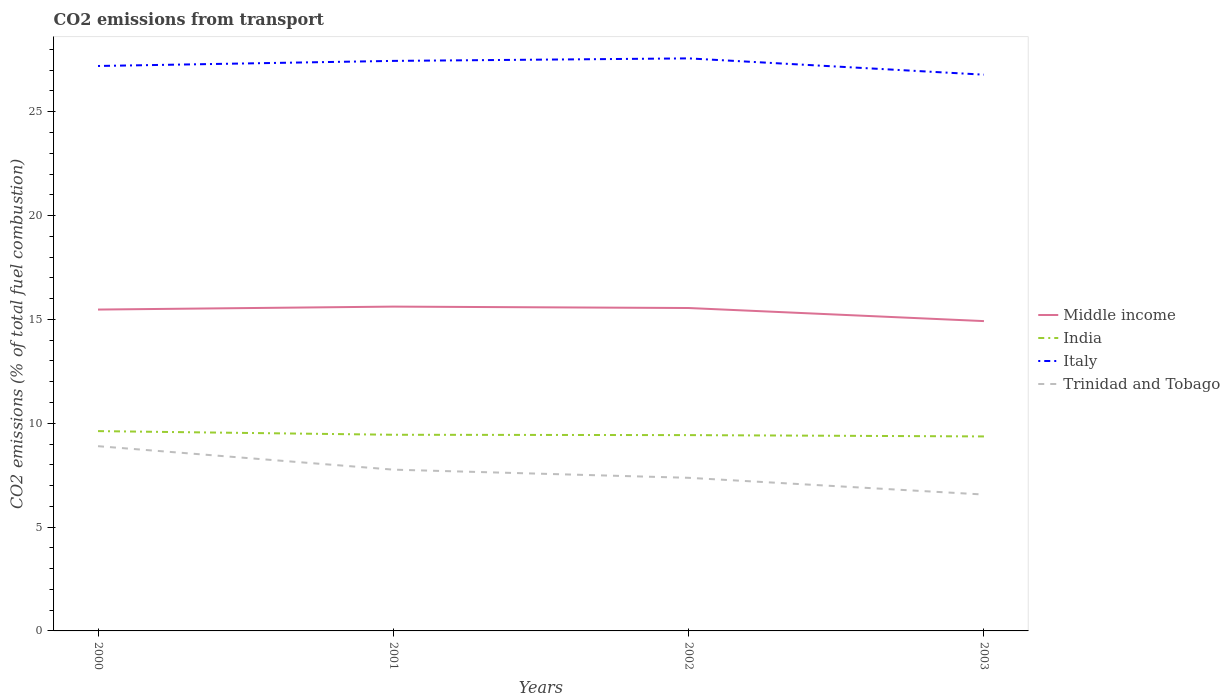Does the line corresponding to Middle income intersect with the line corresponding to Trinidad and Tobago?
Offer a terse response. No. Across all years, what is the maximum total CO2 emitted in Trinidad and Tobago?
Ensure brevity in your answer.  6.57. What is the total total CO2 emitted in Middle income in the graph?
Provide a succinct answer. 0.63. What is the difference between the highest and the second highest total CO2 emitted in India?
Give a very brief answer. 0.26. Is the total CO2 emitted in Trinidad and Tobago strictly greater than the total CO2 emitted in Italy over the years?
Keep it short and to the point. Yes. How many lines are there?
Your answer should be compact. 4. How many years are there in the graph?
Your response must be concise. 4. Are the values on the major ticks of Y-axis written in scientific E-notation?
Your answer should be compact. No. Where does the legend appear in the graph?
Your answer should be compact. Center right. How are the legend labels stacked?
Your answer should be very brief. Vertical. What is the title of the graph?
Your answer should be compact. CO2 emissions from transport. Does "Sri Lanka" appear as one of the legend labels in the graph?
Keep it short and to the point. No. What is the label or title of the Y-axis?
Provide a succinct answer. CO2 emissions (% of total fuel combustion). What is the CO2 emissions (% of total fuel combustion) of Middle income in 2000?
Provide a short and direct response. 15.47. What is the CO2 emissions (% of total fuel combustion) of India in 2000?
Offer a very short reply. 9.62. What is the CO2 emissions (% of total fuel combustion) in Italy in 2000?
Your answer should be very brief. 27.2. What is the CO2 emissions (% of total fuel combustion) in Trinidad and Tobago in 2000?
Keep it short and to the point. 8.9. What is the CO2 emissions (% of total fuel combustion) in Middle income in 2001?
Offer a terse response. 15.62. What is the CO2 emissions (% of total fuel combustion) in India in 2001?
Provide a succinct answer. 9.45. What is the CO2 emissions (% of total fuel combustion) in Italy in 2001?
Your answer should be very brief. 27.45. What is the CO2 emissions (% of total fuel combustion) of Trinidad and Tobago in 2001?
Your answer should be very brief. 7.77. What is the CO2 emissions (% of total fuel combustion) of Middle income in 2002?
Offer a very short reply. 15.55. What is the CO2 emissions (% of total fuel combustion) in India in 2002?
Your answer should be very brief. 9.43. What is the CO2 emissions (% of total fuel combustion) in Italy in 2002?
Make the answer very short. 27.57. What is the CO2 emissions (% of total fuel combustion) of Trinidad and Tobago in 2002?
Provide a succinct answer. 7.37. What is the CO2 emissions (% of total fuel combustion) in Middle income in 2003?
Your answer should be very brief. 14.92. What is the CO2 emissions (% of total fuel combustion) of India in 2003?
Your response must be concise. 9.37. What is the CO2 emissions (% of total fuel combustion) in Italy in 2003?
Your answer should be compact. 26.79. What is the CO2 emissions (% of total fuel combustion) of Trinidad and Tobago in 2003?
Provide a short and direct response. 6.57. Across all years, what is the maximum CO2 emissions (% of total fuel combustion) of Middle income?
Ensure brevity in your answer.  15.62. Across all years, what is the maximum CO2 emissions (% of total fuel combustion) in India?
Offer a very short reply. 9.62. Across all years, what is the maximum CO2 emissions (% of total fuel combustion) of Italy?
Ensure brevity in your answer.  27.57. Across all years, what is the maximum CO2 emissions (% of total fuel combustion) in Trinidad and Tobago?
Make the answer very short. 8.9. Across all years, what is the minimum CO2 emissions (% of total fuel combustion) of Middle income?
Ensure brevity in your answer.  14.92. Across all years, what is the minimum CO2 emissions (% of total fuel combustion) in India?
Your response must be concise. 9.37. Across all years, what is the minimum CO2 emissions (% of total fuel combustion) in Italy?
Offer a terse response. 26.79. Across all years, what is the minimum CO2 emissions (% of total fuel combustion) of Trinidad and Tobago?
Provide a succinct answer. 6.57. What is the total CO2 emissions (% of total fuel combustion) of Middle income in the graph?
Ensure brevity in your answer.  61.56. What is the total CO2 emissions (% of total fuel combustion) of India in the graph?
Make the answer very short. 37.86. What is the total CO2 emissions (% of total fuel combustion) in Italy in the graph?
Keep it short and to the point. 109.01. What is the total CO2 emissions (% of total fuel combustion) in Trinidad and Tobago in the graph?
Provide a succinct answer. 30.6. What is the difference between the CO2 emissions (% of total fuel combustion) of Middle income in 2000 and that in 2001?
Your response must be concise. -0.14. What is the difference between the CO2 emissions (% of total fuel combustion) in India in 2000 and that in 2001?
Your answer should be compact. 0.18. What is the difference between the CO2 emissions (% of total fuel combustion) of Italy in 2000 and that in 2001?
Provide a succinct answer. -0.25. What is the difference between the CO2 emissions (% of total fuel combustion) in Trinidad and Tobago in 2000 and that in 2001?
Your answer should be very brief. 1.13. What is the difference between the CO2 emissions (% of total fuel combustion) in Middle income in 2000 and that in 2002?
Provide a short and direct response. -0.07. What is the difference between the CO2 emissions (% of total fuel combustion) in India in 2000 and that in 2002?
Your answer should be compact. 0.19. What is the difference between the CO2 emissions (% of total fuel combustion) of Italy in 2000 and that in 2002?
Your answer should be compact. -0.37. What is the difference between the CO2 emissions (% of total fuel combustion) of Trinidad and Tobago in 2000 and that in 2002?
Ensure brevity in your answer.  1.52. What is the difference between the CO2 emissions (% of total fuel combustion) in Middle income in 2000 and that in 2003?
Make the answer very short. 0.56. What is the difference between the CO2 emissions (% of total fuel combustion) of India in 2000 and that in 2003?
Make the answer very short. 0.26. What is the difference between the CO2 emissions (% of total fuel combustion) in Italy in 2000 and that in 2003?
Offer a terse response. 0.42. What is the difference between the CO2 emissions (% of total fuel combustion) of Trinidad and Tobago in 2000 and that in 2003?
Provide a succinct answer. 2.33. What is the difference between the CO2 emissions (% of total fuel combustion) of Middle income in 2001 and that in 2002?
Your answer should be very brief. 0.07. What is the difference between the CO2 emissions (% of total fuel combustion) in India in 2001 and that in 2002?
Offer a terse response. 0.02. What is the difference between the CO2 emissions (% of total fuel combustion) of Italy in 2001 and that in 2002?
Your answer should be compact. -0.12. What is the difference between the CO2 emissions (% of total fuel combustion) in Trinidad and Tobago in 2001 and that in 2002?
Your answer should be very brief. 0.39. What is the difference between the CO2 emissions (% of total fuel combustion) in Middle income in 2001 and that in 2003?
Provide a succinct answer. 0.7. What is the difference between the CO2 emissions (% of total fuel combustion) in India in 2001 and that in 2003?
Your answer should be very brief. 0.08. What is the difference between the CO2 emissions (% of total fuel combustion) of Italy in 2001 and that in 2003?
Provide a short and direct response. 0.66. What is the difference between the CO2 emissions (% of total fuel combustion) of Trinidad and Tobago in 2001 and that in 2003?
Offer a terse response. 1.2. What is the difference between the CO2 emissions (% of total fuel combustion) in Middle income in 2002 and that in 2003?
Ensure brevity in your answer.  0.63. What is the difference between the CO2 emissions (% of total fuel combustion) of India in 2002 and that in 2003?
Keep it short and to the point. 0.06. What is the difference between the CO2 emissions (% of total fuel combustion) in Italy in 2002 and that in 2003?
Give a very brief answer. 0.78. What is the difference between the CO2 emissions (% of total fuel combustion) of Trinidad and Tobago in 2002 and that in 2003?
Offer a very short reply. 0.81. What is the difference between the CO2 emissions (% of total fuel combustion) in Middle income in 2000 and the CO2 emissions (% of total fuel combustion) in India in 2001?
Your answer should be very brief. 6.03. What is the difference between the CO2 emissions (% of total fuel combustion) of Middle income in 2000 and the CO2 emissions (% of total fuel combustion) of Italy in 2001?
Make the answer very short. -11.97. What is the difference between the CO2 emissions (% of total fuel combustion) of Middle income in 2000 and the CO2 emissions (% of total fuel combustion) of Trinidad and Tobago in 2001?
Offer a very short reply. 7.71. What is the difference between the CO2 emissions (% of total fuel combustion) of India in 2000 and the CO2 emissions (% of total fuel combustion) of Italy in 2001?
Offer a terse response. -17.83. What is the difference between the CO2 emissions (% of total fuel combustion) in India in 2000 and the CO2 emissions (% of total fuel combustion) in Trinidad and Tobago in 2001?
Your response must be concise. 1.86. What is the difference between the CO2 emissions (% of total fuel combustion) in Italy in 2000 and the CO2 emissions (% of total fuel combustion) in Trinidad and Tobago in 2001?
Make the answer very short. 19.44. What is the difference between the CO2 emissions (% of total fuel combustion) in Middle income in 2000 and the CO2 emissions (% of total fuel combustion) in India in 2002?
Make the answer very short. 6.05. What is the difference between the CO2 emissions (% of total fuel combustion) of Middle income in 2000 and the CO2 emissions (% of total fuel combustion) of Italy in 2002?
Provide a short and direct response. -12.1. What is the difference between the CO2 emissions (% of total fuel combustion) in Middle income in 2000 and the CO2 emissions (% of total fuel combustion) in Trinidad and Tobago in 2002?
Your answer should be compact. 8.1. What is the difference between the CO2 emissions (% of total fuel combustion) of India in 2000 and the CO2 emissions (% of total fuel combustion) of Italy in 2002?
Your answer should be very brief. -17.95. What is the difference between the CO2 emissions (% of total fuel combustion) in India in 2000 and the CO2 emissions (% of total fuel combustion) in Trinidad and Tobago in 2002?
Keep it short and to the point. 2.25. What is the difference between the CO2 emissions (% of total fuel combustion) of Italy in 2000 and the CO2 emissions (% of total fuel combustion) of Trinidad and Tobago in 2002?
Make the answer very short. 19.83. What is the difference between the CO2 emissions (% of total fuel combustion) of Middle income in 2000 and the CO2 emissions (% of total fuel combustion) of India in 2003?
Your response must be concise. 6.11. What is the difference between the CO2 emissions (% of total fuel combustion) in Middle income in 2000 and the CO2 emissions (% of total fuel combustion) in Italy in 2003?
Give a very brief answer. -11.31. What is the difference between the CO2 emissions (% of total fuel combustion) of Middle income in 2000 and the CO2 emissions (% of total fuel combustion) of Trinidad and Tobago in 2003?
Ensure brevity in your answer.  8.91. What is the difference between the CO2 emissions (% of total fuel combustion) in India in 2000 and the CO2 emissions (% of total fuel combustion) in Italy in 2003?
Provide a short and direct response. -17.16. What is the difference between the CO2 emissions (% of total fuel combustion) in India in 2000 and the CO2 emissions (% of total fuel combustion) in Trinidad and Tobago in 2003?
Offer a terse response. 3.05. What is the difference between the CO2 emissions (% of total fuel combustion) of Italy in 2000 and the CO2 emissions (% of total fuel combustion) of Trinidad and Tobago in 2003?
Provide a succinct answer. 20.64. What is the difference between the CO2 emissions (% of total fuel combustion) of Middle income in 2001 and the CO2 emissions (% of total fuel combustion) of India in 2002?
Offer a terse response. 6.19. What is the difference between the CO2 emissions (% of total fuel combustion) of Middle income in 2001 and the CO2 emissions (% of total fuel combustion) of Italy in 2002?
Provide a short and direct response. -11.95. What is the difference between the CO2 emissions (% of total fuel combustion) in Middle income in 2001 and the CO2 emissions (% of total fuel combustion) in Trinidad and Tobago in 2002?
Offer a terse response. 8.24. What is the difference between the CO2 emissions (% of total fuel combustion) of India in 2001 and the CO2 emissions (% of total fuel combustion) of Italy in 2002?
Offer a terse response. -18.12. What is the difference between the CO2 emissions (% of total fuel combustion) of India in 2001 and the CO2 emissions (% of total fuel combustion) of Trinidad and Tobago in 2002?
Offer a terse response. 2.07. What is the difference between the CO2 emissions (% of total fuel combustion) in Italy in 2001 and the CO2 emissions (% of total fuel combustion) in Trinidad and Tobago in 2002?
Keep it short and to the point. 20.08. What is the difference between the CO2 emissions (% of total fuel combustion) of Middle income in 2001 and the CO2 emissions (% of total fuel combustion) of India in 2003?
Ensure brevity in your answer.  6.25. What is the difference between the CO2 emissions (% of total fuel combustion) in Middle income in 2001 and the CO2 emissions (% of total fuel combustion) in Italy in 2003?
Your answer should be compact. -11.17. What is the difference between the CO2 emissions (% of total fuel combustion) of Middle income in 2001 and the CO2 emissions (% of total fuel combustion) of Trinidad and Tobago in 2003?
Provide a succinct answer. 9.05. What is the difference between the CO2 emissions (% of total fuel combustion) of India in 2001 and the CO2 emissions (% of total fuel combustion) of Italy in 2003?
Your answer should be very brief. -17.34. What is the difference between the CO2 emissions (% of total fuel combustion) in India in 2001 and the CO2 emissions (% of total fuel combustion) in Trinidad and Tobago in 2003?
Your answer should be compact. 2.88. What is the difference between the CO2 emissions (% of total fuel combustion) in Italy in 2001 and the CO2 emissions (% of total fuel combustion) in Trinidad and Tobago in 2003?
Ensure brevity in your answer.  20.88. What is the difference between the CO2 emissions (% of total fuel combustion) in Middle income in 2002 and the CO2 emissions (% of total fuel combustion) in India in 2003?
Keep it short and to the point. 6.18. What is the difference between the CO2 emissions (% of total fuel combustion) in Middle income in 2002 and the CO2 emissions (% of total fuel combustion) in Italy in 2003?
Your response must be concise. -11.24. What is the difference between the CO2 emissions (% of total fuel combustion) in Middle income in 2002 and the CO2 emissions (% of total fuel combustion) in Trinidad and Tobago in 2003?
Make the answer very short. 8.98. What is the difference between the CO2 emissions (% of total fuel combustion) in India in 2002 and the CO2 emissions (% of total fuel combustion) in Italy in 2003?
Your answer should be compact. -17.36. What is the difference between the CO2 emissions (% of total fuel combustion) in India in 2002 and the CO2 emissions (% of total fuel combustion) in Trinidad and Tobago in 2003?
Your response must be concise. 2.86. What is the difference between the CO2 emissions (% of total fuel combustion) in Italy in 2002 and the CO2 emissions (% of total fuel combustion) in Trinidad and Tobago in 2003?
Provide a succinct answer. 21. What is the average CO2 emissions (% of total fuel combustion) in Middle income per year?
Your answer should be very brief. 15.39. What is the average CO2 emissions (% of total fuel combustion) of India per year?
Make the answer very short. 9.47. What is the average CO2 emissions (% of total fuel combustion) in Italy per year?
Provide a short and direct response. 27.25. What is the average CO2 emissions (% of total fuel combustion) in Trinidad and Tobago per year?
Ensure brevity in your answer.  7.65. In the year 2000, what is the difference between the CO2 emissions (% of total fuel combustion) in Middle income and CO2 emissions (% of total fuel combustion) in India?
Ensure brevity in your answer.  5.85. In the year 2000, what is the difference between the CO2 emissions (% of total fuel combustion) in Middle income and CO2 emissions (% of total fuel combustion) in Italy?
Make the answer very short. -11.73. In the year 2000, what is the difference between the CO2 emissions (% of total fuel combustion) in Middle income and CO2 emissions (% of total fuel combustion) in Trinidad and Tobago?
Give a very brief answer. 6.58. In the year 2000, what is the difference between the CO2 emissions (% of total fuel combustion) of India and CO2 emissions (% of total fuel combustion) of Italy?
Keep it short and to the point. -17.58. In the year 2000, what is the difference between the CO2 emissions (% of total fuel combustion) in India and CO2 emissions (% of total fuel combustion) in Trinidad and Tobago?
Offer a very short reply. 0.73. In the year 2000, what is the difference between the CO2 emissions (% of total fuel combustion) in Italy and CO2 emissions (% of total fuel combustion) in Trinidad and Tobago?
Keep it short and to the point. 18.31. In the year 2001, what is the difference between the CO2 emissions (% of total fuel combustion) in Middle income and CO2 emissions (% of total fuel combustion) in India?
Your answer should be very brief. 6.17. In the year 2001, what is the difference between the CO2 emissions (% of total fuel combustion) in Middle income and CO2 emissions (% of total fuel combustion) in Italy?
Ensure brevity in your answer.  -11.83. In the year 2001, what is the difference between the CO2 emissions (% of total fuel combustion) of Middle income and CO2 emissions (% of total fuel combustion) of Trinidad and Tobago?
Your answer should be very brief. 7.85. In the year 2001, what is the difference between the CO2 emissions (% of total fuel combustion) in India and CO2 emissions (% of total fuel combustion) in Italy?
Ensure brevity in your answer.  -18. In the year 2001, what is the difference between the CO2 emissions (% of total fuel combustion) of India and CO2 emissions (% of total fuel combustion) of Trinidad and Tobago?
Your response must be concise. 1.68. In the year 2001, what is the difference between the CO2 emissions (% of total fuel combustion) of Italy and CO2 emissions (% of total fuel combustion) of Trinidad and Tobago?
Provide a short and direct response. 19.68. In the year 2002, what is the difference between the CO2 emissions (% of total fuel combustion) in Middle income and CO2 emissions (% of total fuel combustion) in India?
Offer a terse response. 6.12. In the year 2002, what is the difference between the CO2 emissions (% of total fuel combustion) of Middle income and CO2 emissions (% of total fuel combustion) of Italy?
Offer a terse response. -12.02. In the year 2002, what is the difference between the CO2 emissions (% of total fuel combustion) of Middle income and CO2 emissions (% of total fuel combustion) of Trinidad and Tobago?
Make the answer very short. 8.18. In the year 2002, what is the difference between the CO2 emissions (% of total fuel combustion) of India and CO2 emissions (% of total fuel combustion) of Italy?
Keep it short and to the point. -18.14. In the year 2002, what is the difference between the CO2 emissions (% of total fuel combustion) of India and CO2 emissions (% of total fuel combustion) of Trinidad and Tobago?
Give a very brief answer. 2.06. In the year 2002, what is the difference between the CO2 emissions (% of total fuel combustion) in Italy and CO2 emissions (% of total fuel combustion) in Trinidad and Tobago?
Provide a succinct answer. 20.2. In the year 2003, what is the difference between the CO2 emissions (% of total fuel combustion) of Middle income and CO2 emissions (% of total fuel combustion) of India?
Provide a succinct answer. 5.55. In the year 2003, what is the difference between the CO2 emissions (% of total fuel combustion) of Middle income and CO2 emissions (% of total fuel combustion) of Italy?
Keep it short and to the point. -11.87. In the year 2003, what is the difference between the CO2 emissions (% of total fuel combustion) in Middle income and CO2 emissions (% of total fuel combustion) in Trinidad and Tobago?
Make the answer very short. 8.35. In the year 2003, what is the difference between the CO2 emissions (% of total fuel combustion) of India and CO2 emissions (% of total fuel combustion) of Italy?
Provide a short and direct response. -17.42. In the year 2003, what is the difference between the CO2 emissions (% of total fuel combustion) in India and CO2 emissions (% of total fuel combustion) in Trinidad and Tobago?
Provide a succinct answer. 2.8. In the year 2003, what is the difference between the CO2 emissions (% of total fuel combustion) in Italy and CO2 emissions (% of total fuel combustion) in Trinidad and Tobago?
Offer a very short reply. 20.22. What is the ratio of the CO2 emissions (% of total fuel combustion) in Middle income in 2000 to that in 2001?
Your answer should be very brief. 0.99. What is the ratio of the CO2 emissions (% of total fuel combustion) in India in 2000 to that in 2001?
Your response must be concise. 1.02. What is the ratio of the CO2 emissions (% of total fuel combustion) of Trinidad and Tobago in 2000 to that in 2001?
Give a very brief answer. 1.15. What is the ratio of the CO2 emissions (% of total fuel combustion) in India in 2000 to that in 2002?
Give a very brief answer. 1.02. What is the ratio of the CO2 emissions (% of total fuel combustion) of Italy in 2000 to that in 2002?
Offer a terse response. 0.99. What is the ratio of the CO2 emissions (% of total fuel combustion) of Trinidad and Tobago in 2000 to that in 2002?
Give a very brief answer. 1.21. What is the ratio of the CO2 emissions (% of total fuel combustion) in Middle income in 2000 to that in 2003?
Provide a short and direct response. 1.04. What is the ratio of the CO2 emissions (% of total fuel combustion) of India in 2000 to that in 2003?
Keep it short and to the point. 1.03. What is the ratio of the CO2 emissions (% of total fuel combustion) in Italy in 2000 to that in 2003?
Offer a terse response. 1.02. What is the ratio of the CO2 emissions (% of total fuel combustion) in Trinidad and Tobago in 2000 to that in 2003?
Provide a short and direct response. 1.35. What is the ratio of the CO2 emissions (% of total fuel combustion) in Middle income in 2001 to that in 2002?
Your answer should be compact. 1. What is the ratio of the CO2 emissions (% of total fuel combustion) in India in 2001 to that in 2002?
Your response must be concise. 1. What is the ratio of the CO2 emissions (% of total fuel combustion) of Trinidad and Tobago in 2001 to that in 2002?
Make the answer very short. 1.05. What is the ratio of the CO2 emissions (% of total fuel combustion) in Middle income in 2001 to that in 2003?
Provide a succinct answer. 1.05. What is the ratio of the CO2 emissions (% of total fuel combustion) in India in 2001 to that in 2003?
Your answer should be compact. 1.01. What is the ratio of the CO2 emissions (% of total fuel combustion) in Italy in 2001 to that in 2003?
Your response must be concise. 1.02. What is the ratio of the CO2 emissions (% of total fuel combustion) in Trinidad and Tobago in 2001 to that in 2003?
Provide a short and direct response. 1.18. What is the ratio of the CO2 emissions (% of total fuel combustion) of Middle income in 2002 to that in 2003?
Ensure brevity in your answer.  1.04. What is the ratio of the CO2 emissions (% of total fuel combustion) of India in 2002 to that in 2003?
Offer a terse response. 1.01. What is the ratio of the CO2 emissions (% of total fuel combustion) of Italy in 2002 to that in 2003?
Your response must be concise. 1.03. What is the ratio of the CO2 emissions (% of total fuel combustion) of Trinidad and Tobago in 2002 to that in 2003?
Your answer should be very brief. 1.12. What is the difference between the highest and the second highest CO2 emissions (% of total fuel combustion) of Middle income?
Your answer should be compact. 0.07. What is the difference between the highest and the second highest CO2 emissions (% of total fuel combustion) of India?
Provide a succinct answer. 0.18. What is the difference between the highest and the second highest CO2 emissions (% of total fuel combustion) in Italy?
Your answer should be compact. 0.12. What is the difference between the highest and the second highest CO2 emissions (% of total fuel combustion) in Trinidad and Tobago?
Give a very brief answer. 1.13. What is the difference between the highest and the lowest CO2 emissions (% of total fuel combustion) in Middle income?
Provide a succinct answer. 0.7. What is the difference between the highest and the lowest CO2 emissions (% of total fuel combustion) in India?
Your answer should be compact. 0.26. What is the difference between the highest and the lowest CO2 emissions (% of total fuel combustion) in Italy?
Make the answer very short. 0.78. What is the difference between the highest and the lowest CO2 emissions (% of total fuel combustion) in Trinidad and Tobago?
Provide a short and direct response. 2.33. 